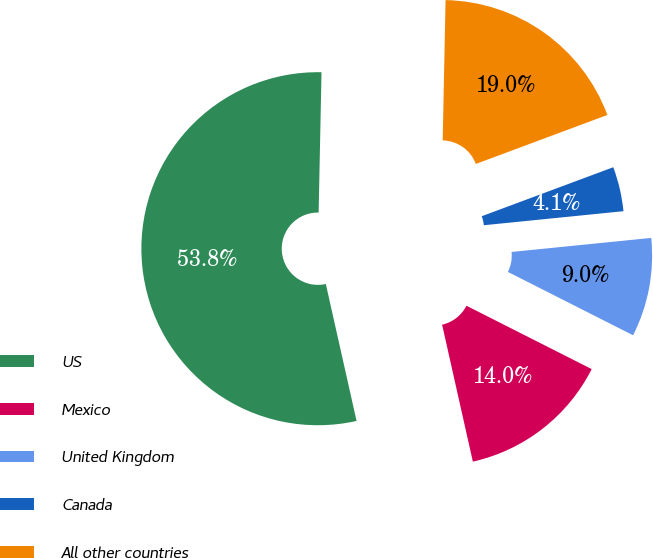Convert chart. <chart><loc_0><loc_0><loc_500><loc_500><pie_chart><fcel>US<fcel>Mexico<fcel>United Kingdom<fcel>Canada<fcel>All other countries<nl><fcel>53.84%<fcel>14.03%<fcel>9.05%<fcel>4.08%<fcel>19.0%<nl></chart> 